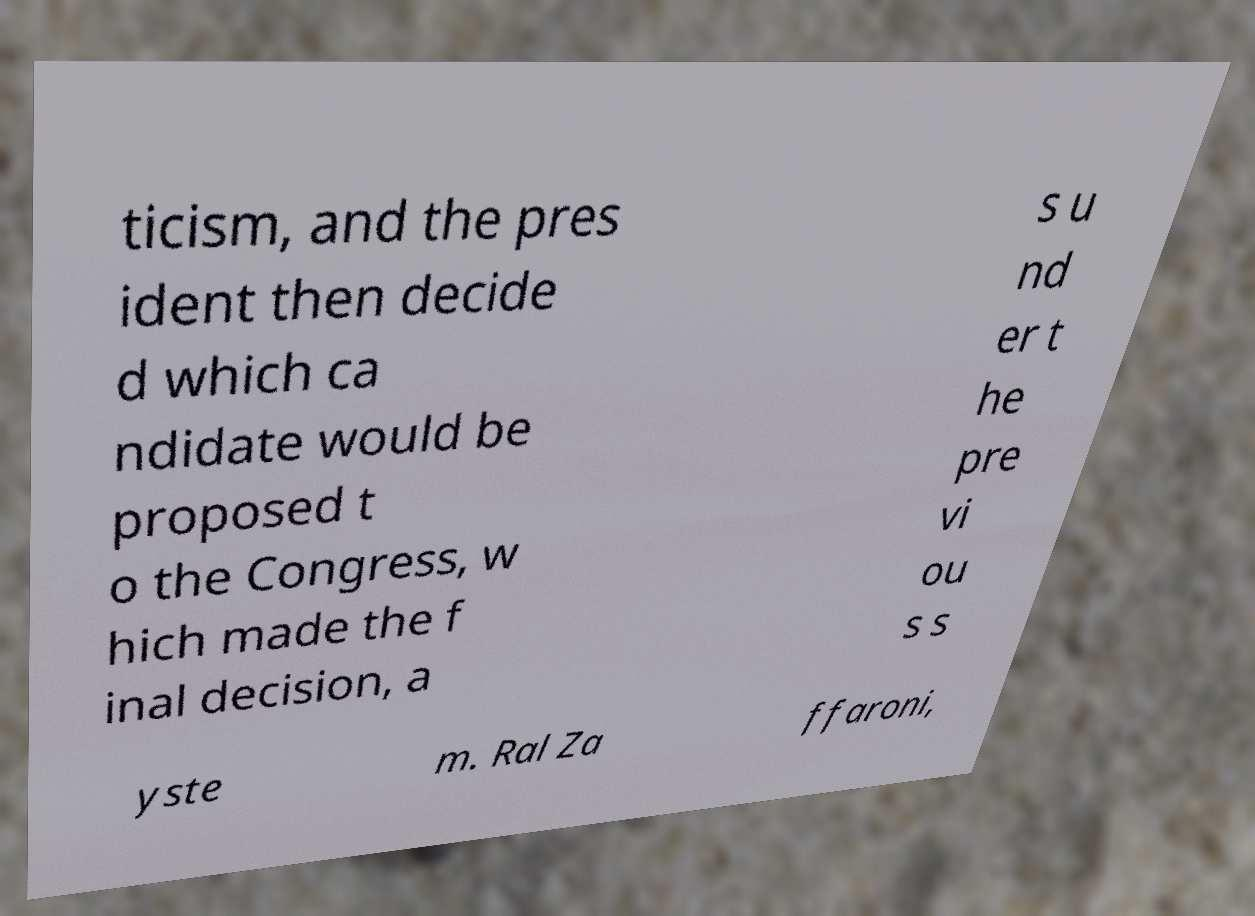For documentation purposes, I need the text within this image transcribed. Could you provide that? ticism, and the pres ident then decide d which ca ndidate would be proposed t o the Congress, w hich made the f inal decision, a s u nd er t he pre vi ou s s yste m. Ral Za ffaroni, 